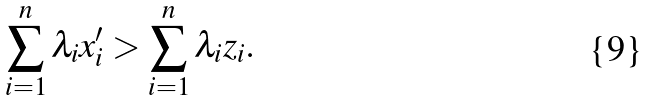Convert formula to latex. <formula><loc_0><loc_0><loc_500><loc_500>\sum _ { i = 1 } ^ { n } \lambda _ { i } x ^ { \prime } _ { i } & > \sum _ { i = 1 } ^ { n } \lambda _ { i } z _ { i } .</formula> 